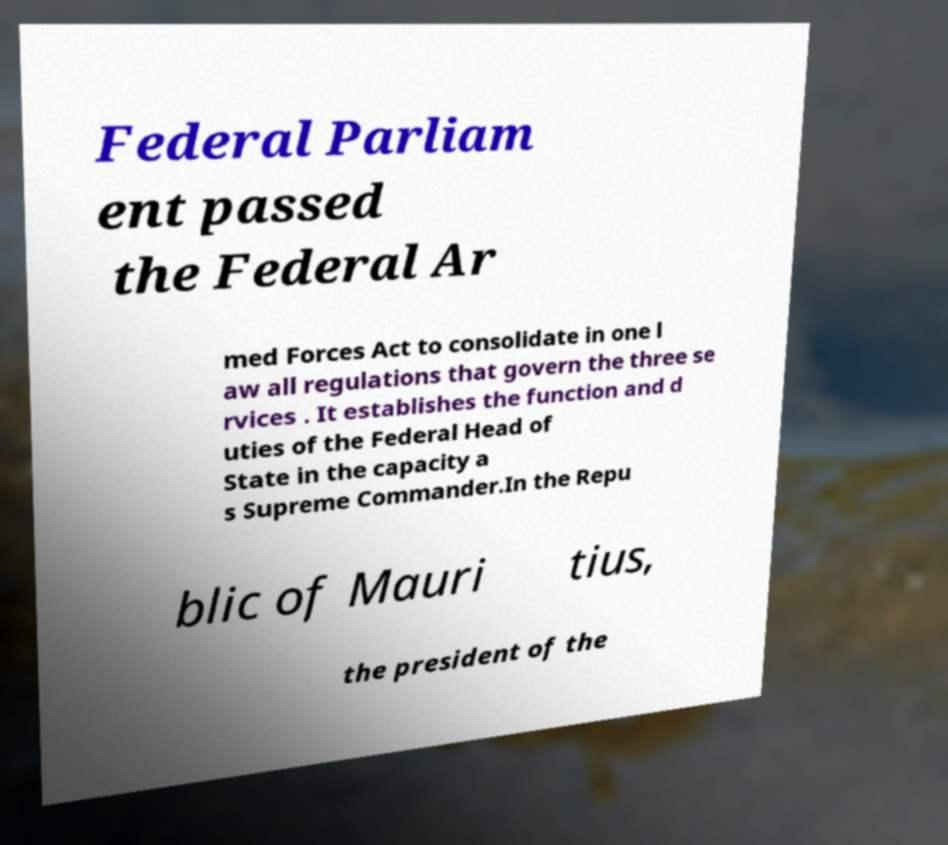I need the written content from this picture converted into text. Can you do that? Federal Parliam ent passed the Federal Ar med Forces Act to consolidate in one l aw all regulations that govern the three se rvices . It establishes the function and d uties of the Federal Head of State in the capacity a s Supreme Commander.In the Repu blic of Mauri tius, the president of the 